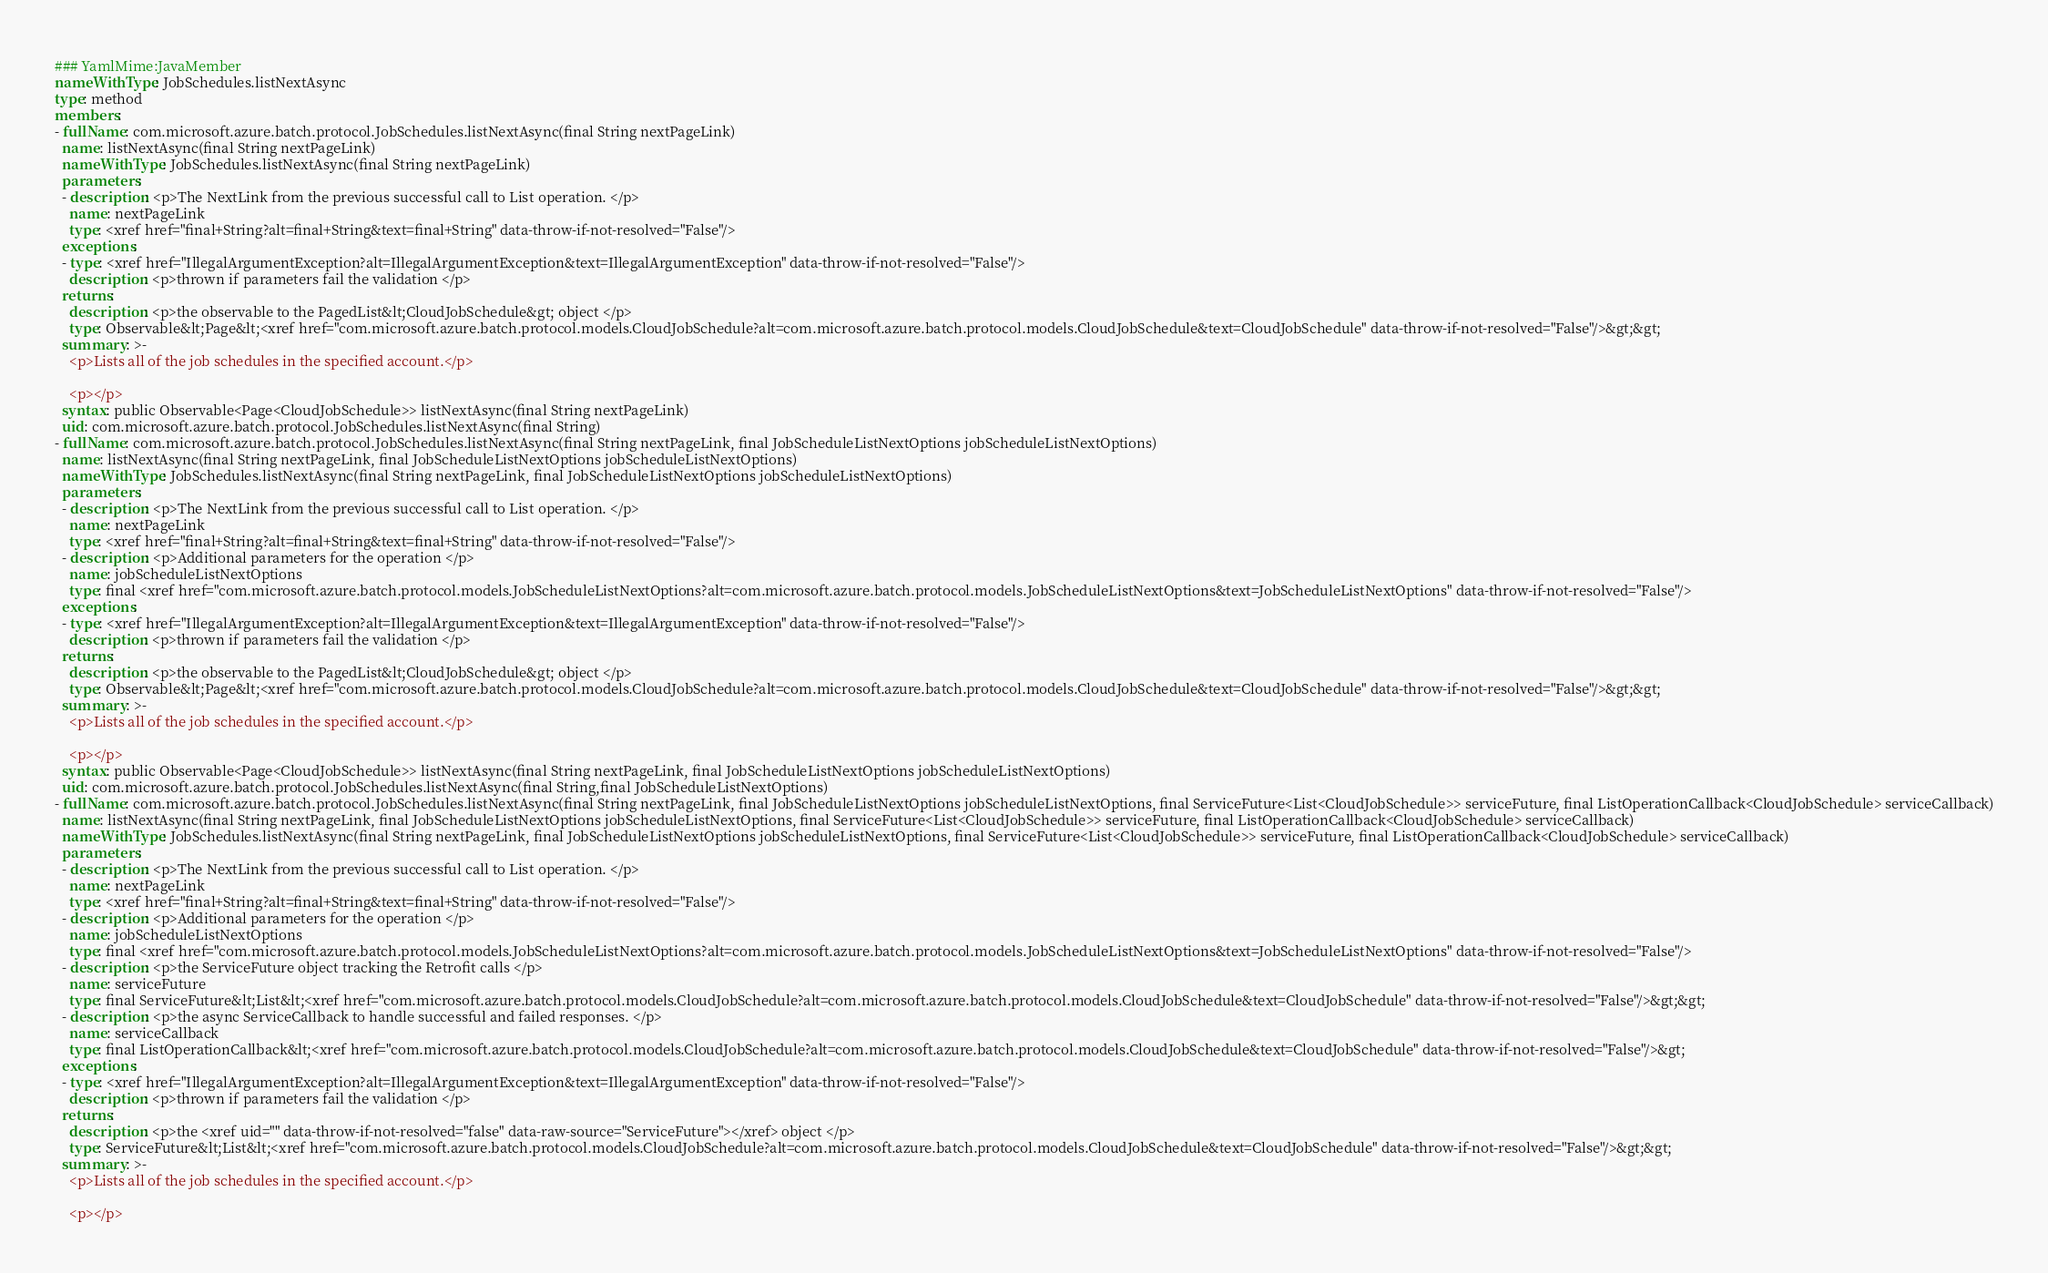Convert code to text. <code><loc_0><loc_0><loc_500><loc_500><_YAML_>### YamlMime:JavaMember
nameWithType: JobSchedules.listNextAsync
type: method
members:
- fullName: com.microsoft.azure.batch.protocol.JobSchedules.listNextAsync(final String nextPageLink)
  name: listNextAsync(final String nextPageLink)
  nameWithType: JobSchedules.listNextAsync(final String nextPageLink)
  parameters:
  - description: <p>The NextLink from the previous successful call to List operation. </p>
    name: nextPageLink
    type: <xref href="final+String?alt=final+String&text=final+String" data-throw-if-not-resolved="False"/>
  exceptions:
  - type: <xref href="IllegalArgumentException?alt=IllegalArgumentException&text=IllegalArgumentException" data-throw-if-not-resolved="False"/>
    description: <p>thrown if parameters fail the validation </p>
  returns:
    description: <p>the observable to the PagedList&lt;CloudJobSchedule&gt; object </p>
    type: Observable&lt;Page&lt;<xref href="com.microsoft.azure.batch.protocol.models.CloudJobSchedule?alt=com.microsoft.azure.batch.protocol.models.CloudJobSchedule&text=CloudJobSchedule" data-throw-if-not-resolved="False"/>&gt;&gt;
  summary: >-
    <p>Lists all of the job schedules in the specified account.</p>

    <p></p>
  syntax: public Observable<Page<CloudJobSchedule>> listNextAsync(final String nextPageLink)
  uid: com.microsoft.azure.batch.protocol.JobSchedules.listNextAsync(final String)
- fullName: com.microsoft.azure.batch.protocol.JobSchedules.listNextAsync(final String nextPageLink, final JobScheduleListNextOptions jobScheduleListNextOptions)
  name: listNextAsync(final String nextPageLink, final JobScheduleListNextOptions jobScheduleListNextOptions)
  nameWithType: JobSchedules.listNextAsync(final String nextPageLink, final JobScheduleListNextOptions jobScheduleListNextOptions)
  parameters:
  - description: <p>The NextLink from the previous successful call to List operation. </p>
    name: nextPageLink
    type: <xref href="final+String?alt=final+String&text=final+String" data-throw-if-not-resolved="False"/>
  - description: <p>Additional parameters for the operation </p>
    name: jobScheduleListNextOptions
    type: final <xref href="com.microsoft.azure.batch.protocol.models.JobScheduleListNextOptions?alt=com.microsoft.azure.batch.protocol.models.JobScheduleListNextOptions&text=JobScheduleListNextOptions" data-throw-if-not-resolved="False"/>
  exceptions:
  - type: <xref href="IllegalArgumentException?alt=IllegalArgumentException&text=IllegalArgumentException" data-throw-if-not-resolved="False"/>
    description: <p>thrown if parameters fail the validation </p>
  returns:
    description: <p>the observable to the PagedList&lt;CloudJobSchedule&gt; object </p>
    type: Observable&lt;Page&lt;<xref href="com.microsoft.azure.batch.protocol.models.CloudJobSchedule?alt=com.microsoft.azure.batch.protocol.models.CloudJobSchedule&text=CloudJobSchedule" data-throw-if-not-resolved="False"/>&gt;&gt;
  summary: >-
    <p>Lists all of the job schedules in the specified account.</p>

    <p></p>
  syntax: public Observable<Page<CloudJobSchedule>> listNextAsync(final String nextPageLink, final JobScheduleListNextOptions jobScheduleListNextOptions)
  uid: com.microsoft.azure.batch.protocol.JobSchedules.listNextAsync(final String,final JobScheduleListNextOptions)
- fullName: com.microsoft.azure.batch.protocol.JobSchedules.listNextAsync(final String nextPageLink, final JobScheduleListNextOptions jobScheduleListNextOptions, final ServiceFuture<List<CloudJobSchedule>> serviceFuture, final ListOperationCallback<CloudJobSchedule> serviceCallback)
  name: listNextAsync(final String nextPageLink, final JobScheduleListNextOptions jobScheduleListNextOptions, final ServiceFuture<List<CloudJobSchedule>> serviceFuture, final ListOperationCallback<CloudJobSchedule> serviceCallback)
  nameWithType: JobSchedules.listNextAsync(final String nextPageLink, final JobScheduleListNextOptions jobScheduleListNextOptions, final ServiceFuture<List<CloudJobSchedule>> serviceFuture, final ListOperationCallback<CloudJobSchedule> serviceCallback)
  parameters:
  - description: <p>The NextLink from the previous successful call to List operation. </p>
    name: nextPageLink
    type: <xref href="final+String?alt=final+String&text=final+String" data-throw-if-not-resolved="False"/>
  - description: <p>Additional parameters for the operation </p>
    name: jobScheduleListNextOptions
    type: final <xref href="com.microsoft.azure.batch.protocol.models.JobScheduleListNextOptions?alt=com.microsoft.azure.batch.protocol.models.JobScheduleListNextOptions&text=JobScheduleListNextOptions" data-throw-if-not-resolved="False"/>
  - description: <p>the ServiceFuture object tracking the Retrofit calls </p>
    name: serviceFuture
    type: final ServiceFuture&lt;List&lt;<xref href="com.microsoft.azure.batch.protocol.models.CloudJobSchedule?alt=com.microsoft.azure.batch.protocol.models.CloudJobSchedule&text=CloudJobSchedule" data-throw-if-not-resolved="False"/>&gt;&gt;
  - description: <p>the async ServiceCallback to handle successful and failed responses. </p>
    name: serviceCallback
    type: final ListOperationCallback&lt;<xref href="com.microsoft.azure.batch.protocol.models.CloudJobSchedule?alt=com.microsoft.azure.batch.protocol.models.CloudJobSchedule&text=CloudJobSchedule" data-throw-if-not-resolved="False"/>&gt;
  exceptions:
  - type: <xref href="IllegalArgumentException?alt=IllegalArgumentException&text=IllegalArgumentException" data-throw-if-not-resolved="False"/>
    description: <p>thrown if parameters fail the validation </p>
  returns:
    description: <p>the <xref uid="" data-throw-if-not-resolved="false" data-raw-source="ServiceFuture"></xref> object </p>
    type: ServiceFuture&lt;List&lt;<xref href="com.microsoft.azure.batch.protocol.models.CloudJobSchedule?alt=com.microsoft.azure.batch.protocol.models.CloudJobSchedule&text=CloudJobSchedule" data-throw-if-not-resolved="False"/>&gt;&gt;
  summary: >-
    <p>Lists all of the job schedules in the specified account.</p>

    <p></p></code> 